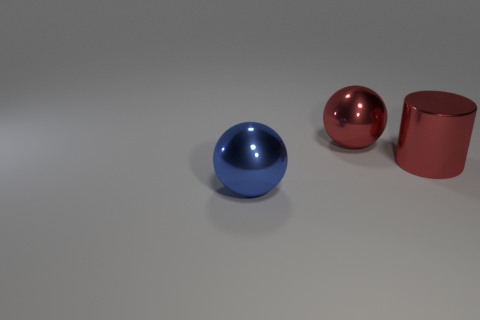Add 2 large spheres. How many objects exist? 5 Subtract all red balls. How many balls are left? 1 Subtract all cylinders. How many objects are left? 2 Subtract all purple cubes. How many red spheres are left? 1 Subtract all large blue objects. Subtract all blue spheres. How many objects are left? 1 Add 3 spheres. How many spheres are left? 5 Add 1 tiny yellow shiny spheres. How many tiny yellow shiny spheres exist? 1 Subtract 0 blue cubes. How many objects are left? 3 Subtract all yellow spheres. Subtract all brown cubes. How many spheres are left? 2 